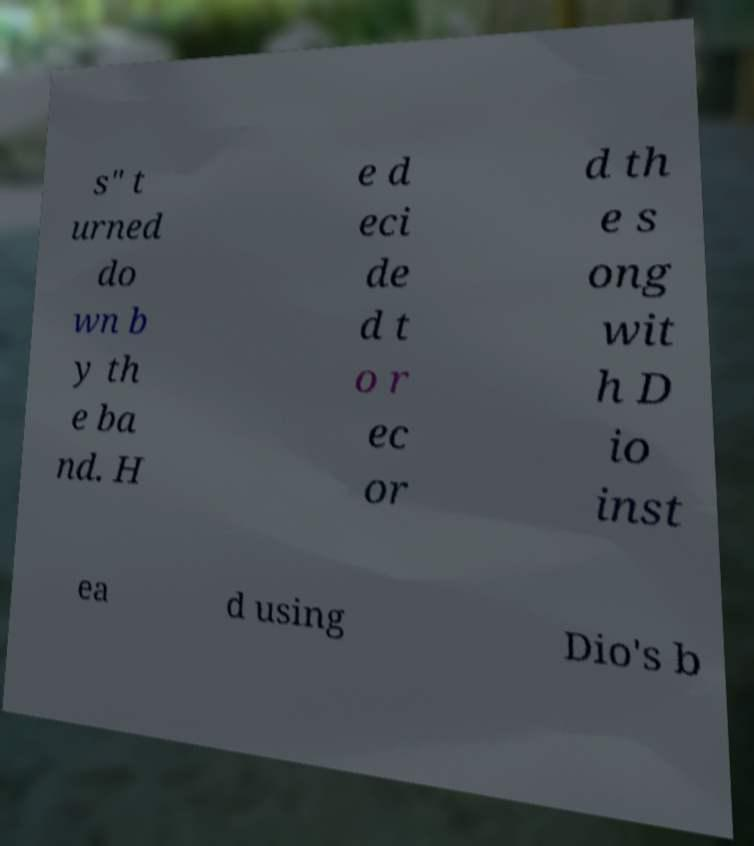Please identify and transcribe the text found in this image. s" t urned do wn b y th e ba nd. H e d eci de d t o r ec or d th e s ong wit h D io inst ea d using Dio's b 